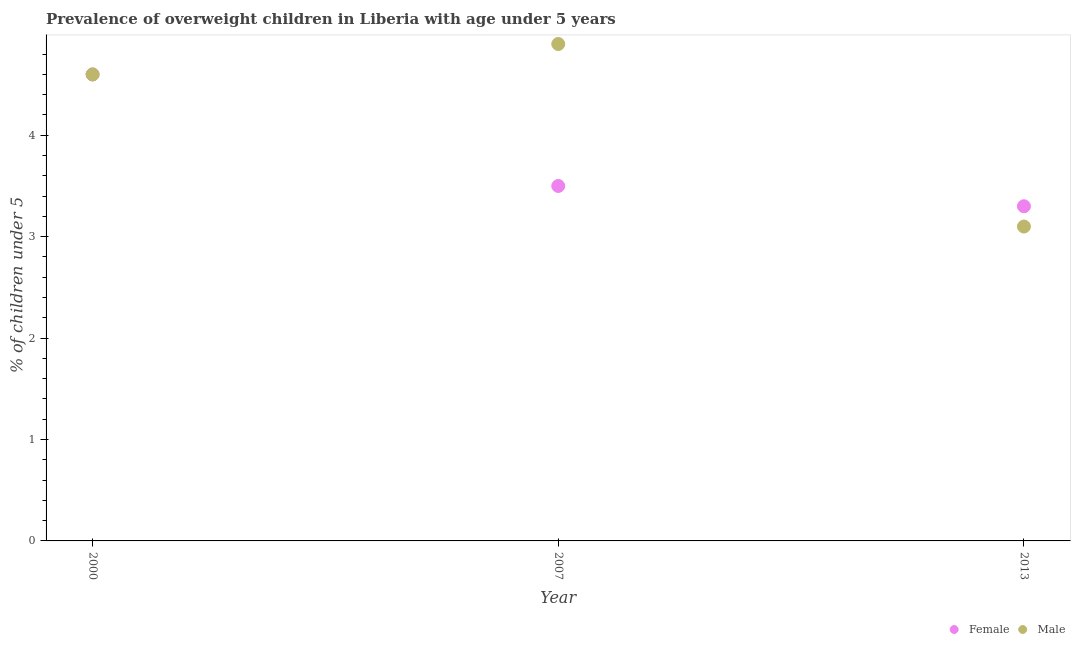How many different coloured dotlines are there?
Give a very brief answer. 2. Is the number of dotlines equal to the number of legend labels?
Give a very brief answer. Yes. What is the percentage of obese male children in 2000?
Provide a short and direct response. 4.6. Across all years, what is the maximum percentage of obese male children?
Offer a terse response. 4.9. Across all years, what is the minimum percentage of obese female children?
Your answer should be compact. 3.3. In which year was the percentage of obese male children maximum?
Offer a very short reply. 2007. In which year was the percentage of obese female children minimum?
Your answer should be very brief. 2013. What is the total percentage of obese female children in the graph?
Provide a succinct answer. 11.4. What is the difference between the percentage of obese male children in 2007 and that in 2013?
Your response must be concise. 1.8. What is the difference between the percentage of obese male children in 2007 and the percentage of obese female children in 2000?
Your response must be concise. 0.3. What is the average percentage of obese male children per year?
Keep it short and to the point. 4.2. In the year 2007, what is the difference between the percentage of obese male children and percentage of obese female children?
Offer a very short reply. 1.4. What is the ratio of the percentage of obese male children in 2000 to that in 2013?
Ensure brevity in your answer.  1.48. Is the difference between the percentage of obese male children in 2000 and 2013 greater than the difference between the percentage of obese female children in 2000 and 2013?
Make the answer very short. Yes. What is the difference between the highest and the second highest percentage of obese female children?
Make the answer very short. 1.1. What is the difference between the highest and the lowest percentage of obese male children?
Your response must be concise. 1.8. Does the percentage of obese male children monotonically increase over the years?
Make the answer very short. No. Is the percentage of obese female children strictly less than the percentage of obese male children over the years?
Provide a short and direct response. No. How many dotlines are there?
Provide a succinct answer. 2. What is the difference between two consecutive major ticks on the Y-axis?
Offer a terse response. 1. Are the values on the major ticks of Y-axis written in scientific E-notation?
Your answer should be very brief. No. Does the graph contain grids?
Offer a very short reply. No. What is the title of the graph?
Your response must be concise. Prevalence of overweight children in Liberia with age under 5 years. What is the label or title of the X-axis?
Give a very brief answer. Year. What is the label or title of the Y-axis?
Provide a succinct answer.  % of children under 5. What is the  % of children under 5 in Female in 2000?
Your answer should be very brief. 4.6. What is the  % of children under 5 in Male in 2000?
Make the answer very short. 4.6. What is the  % of children under 5 of Female in 2007?
Provide a short and direct response. 3.5. What is the  % of children under 5 in Male in 2007?
Offer a terse response. 4.9. What is the  % of children under 5 of Female in 2013?
Offer a terse response. 3.3. What is the  % of children under 5 of Male in 2013?
Offer a very short reply. 3.1. Across all years, what is the maximum  % of children under 5 in Female?
Give a very brief answer. 4.6. Across all years, what is the maximum  % of children under 5 of Male?
Your answer should be compact. 4.9. Across all years, what is the minimum  % of children under 5 in Female?
Offer a terse response. 3.3. Across all years, what is the minimum  % of children under 5 of Male?
Your answer should be compact. 3.1. What is the total  % of children under 5 in Female in the graph?
Your answer should be compact. 11.4. What is the difference between the  % of children under 5 in Female in 2000 and that in 2007?
Your answer should be very brief. 1.1. What is the difference between the  % of children under 5 in Female in 2000 and that in 2013?
Offer a very short reply. 1.3. What is the difference between the  % of children under 5 of Female in 2007 and that in 2013?
Your response must be concise. 0.2. What is the difference between the  % of children under 5 in Female in 2000 and the  % of children under 5 in Male in 2013?
Offer a very short reply. 1.5. What is the average  % of children under 5 of Male per year?
Keep it short and to the point. 4.2. In the year 2000, what is the difference between the  % of children under 5 of Female and  % of children under 5 of Male?
Give a very brief answer. 0. In the year 2013, what is the difference between the  % of children under 5 of Female and  % of children under 5 of Male?
Ensure brevity in your answer.  0.2. What is the ratio of the  % of children under 5 of Female in 2000 to that in 2007?
Give a very brief answer. 1.31. What is the ratio of the  % of children under 5 in Male in 2000 to that in 2007?
Keep it short and to the point. 0.94. What is the ratio of the  % of children under 5 of Female in 2000 to that in 2013?
Your answer should be very brief. 1.39. What is the ratio of the  % of children under 5 of Male in 2000 to that in 2013?
Ensure brevity in your answer.  1.48. What is the ratio of the  % of children under 5 in Female in 2007 to that in 2013?
Provide a short and direct response. 1.06. What is the ratio of the  % of children under 5 of Male in 2007 to that in 2013?
Make the answer very short. 1.58. What is the difference between the highest and the second highest  % of children under 5 of Female?
Offer a very short reply. 1.1. What is the difference between the highest and the second highest  % of children under 5 of Male?
Provide a short and direct response. 0.3. What is the difference between the highest and the lowest  % of children under 5 of Female?
Your response must be concise. 1.3. What is the difference between the highest and the lowest  % of children under 5 in Male?
Your response must be concise. 1.8. 